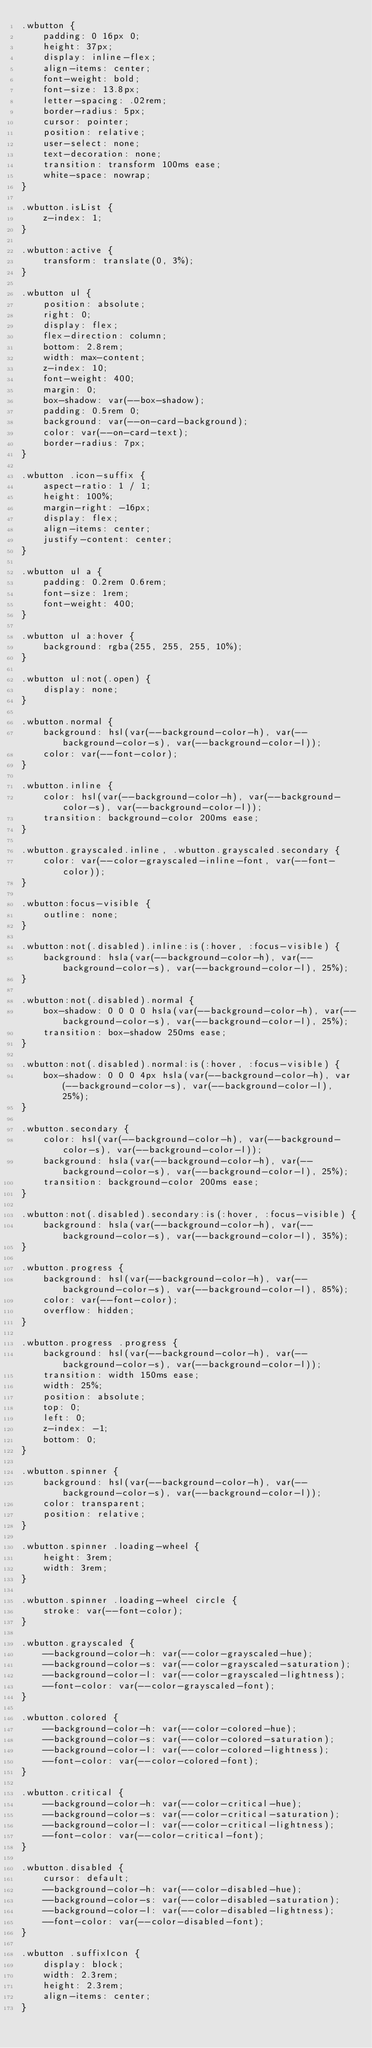Convert code to text. <code><loc_0><loc_0><loc_500><loc_500><_CSS_>.wbutton {
    padding: 0 16px 0;
    height: 37px;
    display: inline-flex;
    align-items: center;
    font-weight: bold;
    font-size: 13.8px;
    letter-spacing: .02rem;
    border-radius: 5px;
    cursor: pointer;
    position: relative;
    user-select: none;
    text-decoration: none;
    transition: transform 100ms ease;
    white-space: nowrap;
}

.wbutton.isList {
    z-index: 1;
}

.wbutton:active {
    transform: translate(0, 3%);
}

.wbutton ul {
    position: absolute;
    right: 0;
    display: flex;
    flex-direction: column;
    bottom: 2.8rem;
    width: max-content;
    z-index: 10;
    font-weight: 400;
    margin: 0;
    box-shadow: var(--box-shadow);
    padding: 0.5rem 0;
    background: var(--on-card-background);
    color: var(--on-card-text);
    border-radius: 7px;
}

.wbutton .icon-suffix {
    aspect-ratio: 1 / 1;
    height: 100%;
    margin-right: -16px;
    display: flex;
    align-items: center;
    justify-content: center;
}

.wbutton ul a {
    padding: 0.2rem 0.6rem;
    font-size: 1rem;
    font-weight: 400;
}

.wbutton ul a:hover {
    background: rgba(255, 255, 255, 10%);
}

.wbutton ul:not(.open) {
    display: none;
}

.wbutton.normal {
    background: hsl(var(--background-color-h), var(--background-color-s), var(--background-color-l));
    color: var(--font-color);
}

.wbutton.inline {
    color: hsl(var(--background-color-h), var(--background-color-s), var(--background-color-l));
    transition: background-color 200ms ease;
}

.wbutton.grayscaled.inline, .wbutton.grayscaled.secondary {
    color: var(--color-grayscaled-inline-font, var(--font-color));
}

.wbutton:focus-visible {
    outline: none;
}

.wbutton:not(.disabled).inline:is(:hover, :focus-visible) {
    background: hsla(var(--background-color-h), var(--background-color-s), var(--background-color-l), 25%);
}

.wbutton:not(.disabled).normal {
    box-shadow: 0 0 0 0 hsla(var(--background-color-h), var(--background-color-s), var(--background-color-l), 25%);
    transition: box-shadow 250ms ease;
}

.wbutton:not(.disabled).normal:is(:hover, :focus-visible) {
    box-shadow: 0 0 0 4px hsla(var(--background-color-h), var(--background-color-s), var(--background-color-l), 25%);
}

.wbutton.secondary {
    color: hsl(var(--background-color-h), var(--background-color-s), var(--background-color-l));
    background: hsla(var(--background-color-h), var(--background-color-s), var(--background-color-l), 25%);
    transition: background-color 200ms ease;
}

.wbutton:not(.disabled).secondary:is(:hover, :focus-visible) {
    background: hsla(var(--background-color-h), var(--background-color-s), var(--background-color-l), 35%);
}

.wbutton.progress {
    background: hsl(var(--background-color-h), var(--background-color-s), var(--background-color-l), 85%);
    color: var(--font-color);
    overflow: hidden;
}

.wbutton.progress .progress {
    background: hsl(var(--background-color-h), var(--background-color-s), var(--background-color-l));
    transition: width 150ms ease;
    width: 25%;
    position: absolute;
    top: 0;
    left: 0;
    z-index: -1;
    bottom: 0;
}

.wbutton.spinner {
    background: hsl(var(--background-color-h), var(--background-color-s), var(--background-color-l));
    color: transparent;
    position: relative;
}

.wbutton.spinner .loading-wheel {
    height: 3rem;
    width: 3rem;
}

.wbutton.spinner .loading-wheel circle {
    stroke: var(--font-color);
}

.wbutton.grayscaled {
    --background-color-h: var(--color-grayscaled-hue);
    --background-color-s: var(--color-grayscaled-saturation);
    --background-color-l: var(--color-grayscaled-lightness);
    --font-color: var(--color-grayscaled-font);
}

.wbutton.colored {
    --background-color-h: var(--color-colored-hue);
    --background-color-s: var(--color-colored-saturation);
    --background-color-l: var(--color-colored-lightness);
    --font-color: var(--color-colored-font);
}

.wbutton.critical {
    --background-color-h: var(--color-critical-hue);
    --background-color-s: var(--color-critical-saturation);
    --background-color-l: var(--color-critical-lightness);
    --font-color: var(--color-critical-font);
}

.wbutton.disabled {
    cursor: default;
    --background-color-h: var(--color-disabled-hue);
    --background-color-s: var(--color-disabled-saturation);
    --background-color-l: var(--color-disabled-lightness);
    --font-color: var(--color-disabled-font);
}

.wbutton .suffixIcon {
    display: block;
    width: 2.3rem;
    height: 2.3rem;
    align-items: center;
}</code> 